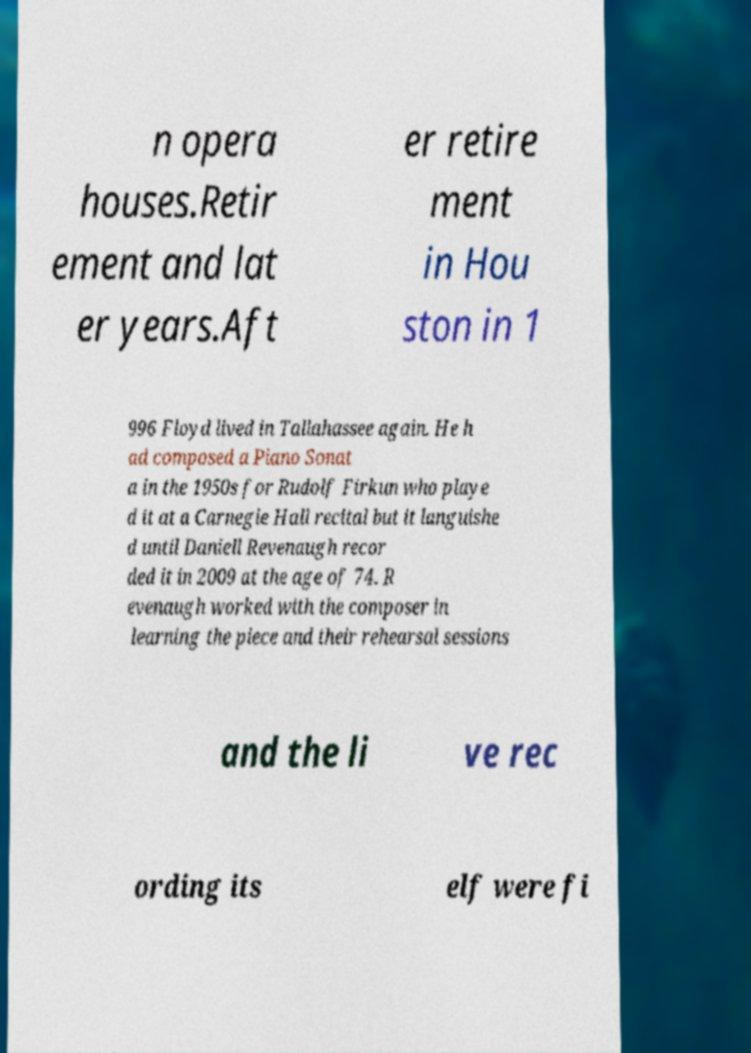What messages or text are displayed in this image? I need them in a readable, typed format. n opera houses.Retir ement and lat er years.Aft er retire ment in Hou ston in 1 996 Floyd lived in Tallahassee again. He h ad composed a Piano Sonat a in the 1950s for Rudolf Firkun who playe d it at a Carnegie Hall recital but it languishe d until Daniell Revenaugh recor ded it in 2009 at the age of 74. R evenaugh worked with the composer in learning the piece and their rehearsal sessions and the li ve rec ording its elf were fi 